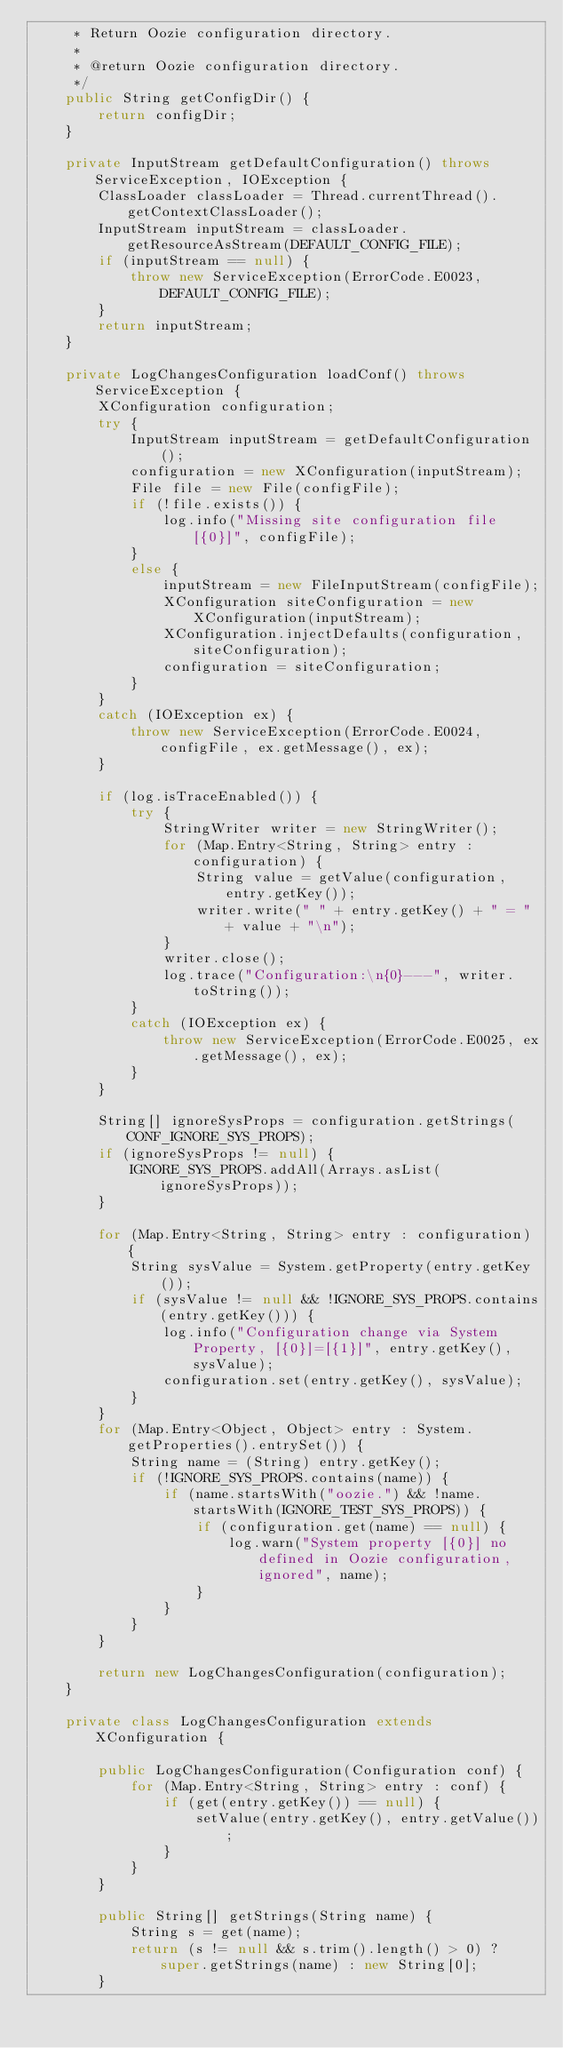<code> <loc_0><loc_0><loc_500><loc_500><_Java_>     * Return Oozie configuration directory.
     *
     * @return Oozie configuration directory.
     */
    public String getConfigDir() {
        return configDir;
    }

    private InputStream getDefaultConfiguration() throws ServiceException, IOException {
        ClassLoader classLoader = Thread.currentThread().getContextClassLoader();
        InputStream inputStream = classLoader.getResourceAsStream(DEFAULT_CONFIG_FILE);
        if (inputStream == null) {
            throw new ServiceException(ErrorCode.E0023, DEFAULT_CONFIG_FILE);
        }
        return inputStream;
    }

    private LogChangesConfiguration loadConf() throws ServiceException {
        XConfiguration configuration;
        try {
            InputStream inputStream = getDefaultConfiguration();
            configuration = new XConfiguration(inputStream);
            File file = new File(configFile);
            if (!file.exists()) {
                log.info("Missing site configuration file [{0}]", configFile);
            }
            else {
                inputStream = new FileInputStream(configFile);
                XConfiguration siteConfiguration = new XConfiguration(inputStream);
                XConfiguration.injectDefaults(configuration, siteConfiguration);
                configuration = siteConfiguration;
            }
        }
        catch (IOException ex) {
            throw new ServiceException(ErrorCode.E0024, configFile, ex.getMessage(), ex);
        }

        if (log.isTraceEnabled()) {
            try {
                StringWriter writer = new StringWriter();
                for (Map.Entry<String, String> entry : configuration) {
                    String value = getValue(configuration, entry.getKey());
                    writer.write(" " + entry.getKey() + " = " + value + "\n");
                }
                writer.close();
                log.trace("Configuration:\n{0}---", writer.toString());
            }
            catch (IOException ex) {
                throw new ServiceException(ErrorCode.E0025, ex.getMessage(), ex);
            }
        }

        String[] ignoreSysProps = configuration.getStrings(CONF_IGNORE_SYS_PROPS);
        if (ignoreSysProps != null) {
            IGNORE_SYS_PROPS.addAll(Arrays.asList(ignoreSysProps));
        }

        for (Map.Entry<String, String> entry : configuration) {
            String sysValue = System.getProperty(entry.getKey());
            if (sysValue != null && !IGNORE_SYS_PROPS.contains(entry.getKey())) {
                log.info("Configuration change via System Property, [{0}]=[{1}]", entry.getKey(), sysValue);
                configuration.set(entry.getKey(), sysValue);
            }
        }
        for (Map.Entry<Object, Object> entry : System.getProperties().entrySet()) {
            String name = (String) entry.getKey();
            if (!IGNORE_SYS_PROPS.contains(name)) {
                if (name.startsWith("oozie.") && !name.startsWith(IGNORE_TEST_SYS_PROPS)) {
                    if (configuration.get(name) == null) {
                        log.warn("System property [{0}] no defined in Oozie configuration, ignored", name);
                    }
                }
            }
        }

        return new LogChangesConfiguration(configuration);
    }

    private class LogChangesConfiguration extends XConfiguration {

        public LogChangesConfiguration(Configuration conf) {
            for (Map.Entry<String, String> entry : conf) {
                if (get(entry.getKey()) == null) {
                    setValue(entry.getKey(), entry.getValue());
                }
            }
        }

        public String[] getStrings(String name) {
            String s = get(name);
            return (s != null && s.trim().length() > 0) ? super.getStrings(name) : new String[0];
        }
</code> 